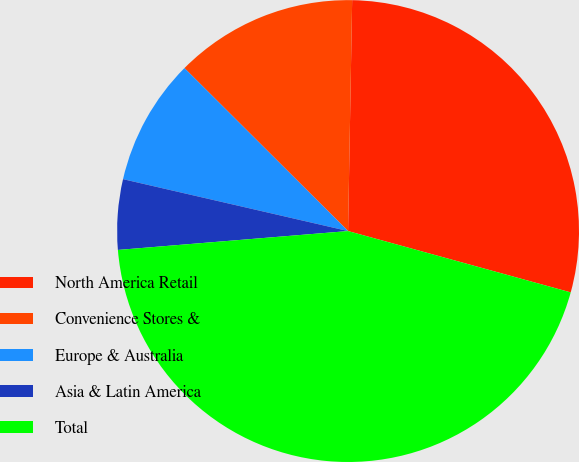Convert chart to OTSL. <chart><loc_0><loc_0><loc_500><loc_500><pie_chart><fcel>North America Retail<fcel>Convenience Stores &<fcel>Europe & Australia<fcel>Asia & Latin America<fcel>Total<nl><fcel>28.99%<fcel>12.81%<fcel>8.86%<fcel>4.91%<fcel>44.41%<nl></chart> 